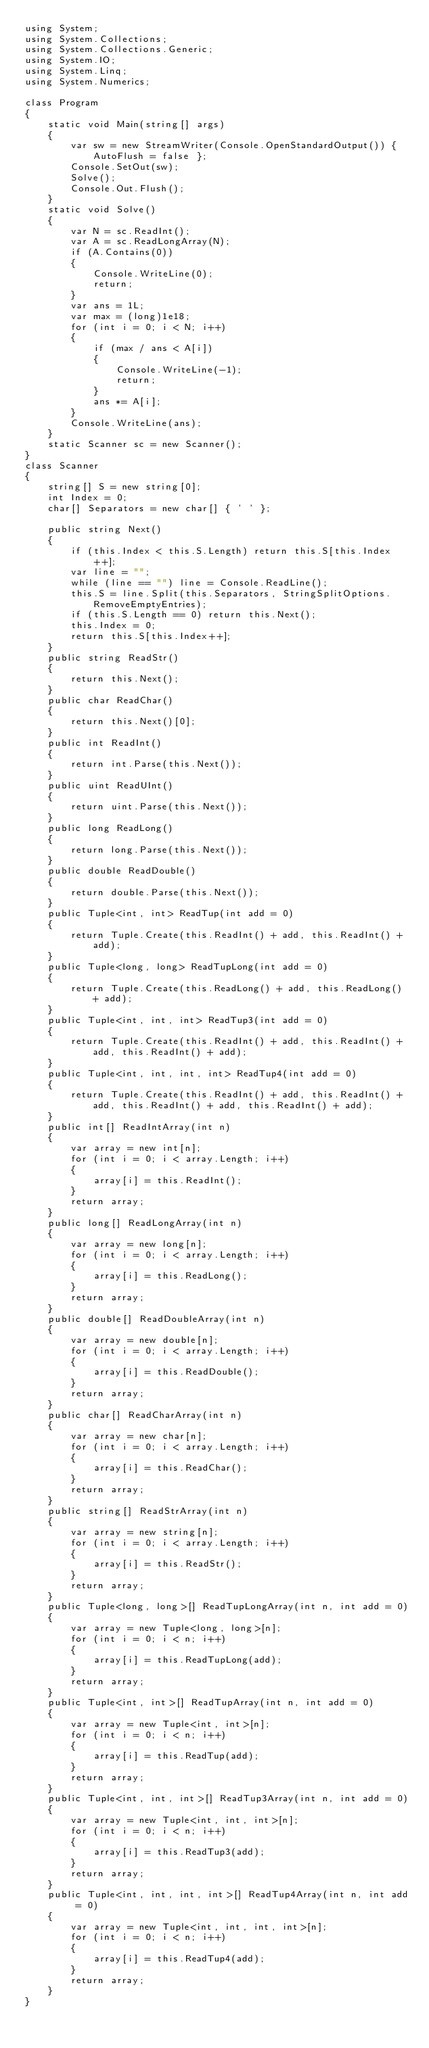Convert code to text. <code><loc_0><loc_0><loc_500><loc_500><_C#_>using System;
using System.Collections;
using System.Collections.Generic;
using System.IO;
using System.Linq;
using System.Numerics;

class Program
{
    static void Main(string[] args)
    {
        var sw = new StreamWriter(Console.OpenStandardOutput()) { AutoFlush = false };
        Console.SetOut(sw);
        Solve();
        Console.Out.Flush();
    }
    static void Solve()
    {
        var N = sc.ReadInt();
        var A = sc.ReadLongArray(N);
        if (A.Contains(0))
        {
            Console.WriteLine(0);
            return;
        }
        var ans = 1L;
        var max = (long)1e18;
        for (int i = 0; i < N; i++)
        {
            if (max / ans < A[i])
            {
                Console.WriteLine(-1);
                return;
            }
            ans *= A[i];
        }
        Console.WriteLine(ans);
    }
    static Scanner sc = new Scanner();
}
class Scanner
{
    string[] S = new string[0];
    int Index = 0;
    char[] Separators = new char[] { ' ' };

    public string Next()
    {
        if (this.Index < this.S.Length) return this.S[this.Index++];
        var line = "";
        while (line == "") line = Console.ReadLine();
        this.S = line.Split(this.Separators, StringSplitOptions.RemoveEmptyEntries);
        if (this.S.Length == 0) return this.Next();
        this.Index = 0;
        return this.S[this.Index++];
    }
    public string ReadStr()
    {
        return this.Next();
    }
    public char ReadChar()
    {
        return this.Next()[0];
    }
    public int ReadInt()
    {
        return int.Parse(this.Next());
    }
    public uint ReadUInt()
    {
        return uint.Parse(this.Next());
    }
    public long ReadLong()
    {
        return long.Parse(this.Next());
    }
    public double ReadDouble()
    {
        return double.Parse(this.Next());
    }
    public Tuple<int, int> ReadTup(int add = 0)
    {
        return Tuple.Create(this.ReadInt() + add, this.ReadInt() + add);
    }
    public Tuple<long, long> ReadTupLong(int add = 0)
    {
        return Tuple.Create(this.ReadLong() + add, this.ReadLong() + add);
    }
    public Tuple<int, int, int> ReadTup3(int add = 0)
    {
        return Tuple.Create(this.ReadInt() + add, this.ReadInt() + add, this.ReadInt() + add);
    }
    public Tuple<int, int, int, int> ReadTup4(int add = 0)
    {
        return Tuple.Create(this.ReadInt() + add, this.ReadInt() + add, this.ReadInt() + add, this.ReadInt() + add);
    }
    public int[] ReadIntArray(int n)
    {
        var array = new int[n];
        for (int i = 0; i < array.Length; i++)
        {
            array[i] = this.ReadInt();
        }
        return array;
    }
    public long[] ReadLongArray(int n)
    {
        var array = new long[n];
        for (int i = 0; i < array.Length; i++)
        {
            array[i] = this.ReadLong();
        }
        return array;
    }
    public double[] ReadDoubleArray(int n)
    {
        var array = new double[n];
        for (int i = 0; i < array.Length; i++)
        {
            array[i] = this.ReadDouble();
        }
        return array;
    }
    public char[] ReadCharArray(int n)
    {
        var array = new char[n];
        for (int i = 0; i < array.Length; i++)
        {
            array[i] = this.ReadChar();
        }
        return array;
    }
    public string[] ReadStrArray(int n)
    {
        var array = new string[n];
        for (int i = 0; i < array.Length; i++)
        {
            array[i] = this.ReadStr();
        }
        return array;
    }
    public Tuple<long, long>[] ReadTupLongArray(int n, int add = 0)
    {
        var array = new Tuple<long, long>[n];
        for (int i = 0; i < n; i++)
        {
            array[i] = this.ReadTupLong(add);
        }
        return array;
    }
    public Tuple<int, int>[] ReadTupArray(int n, int add = 0)
    {
        var array = new Tuple<int, int>[n];
        for (int i = 0; i < n; i++)
        {
            array[i] = this.ReadTup(add);
        }
        return array;
    }
    public Tuple<int, int, int>[] ReadTup3Array(int n, int add = 0)
    {
        var array = new Tuple<int, int, int>[n];
        for (int i = 0; i < n; i++)
        {
            array[i] = this.ReadTup3(add);
        }
        return array;
    }
    public Tuple<int, int, int, int>[] ReadTup4Array(int n, int add = 0)
    {
        var array = new Tuple<int, int, int, int>[n];
        for (int i = 0; i < n; i++)
        {
            array[i] = this.ReadTup4(add);
        }
        return array;
    }
}
</code> 